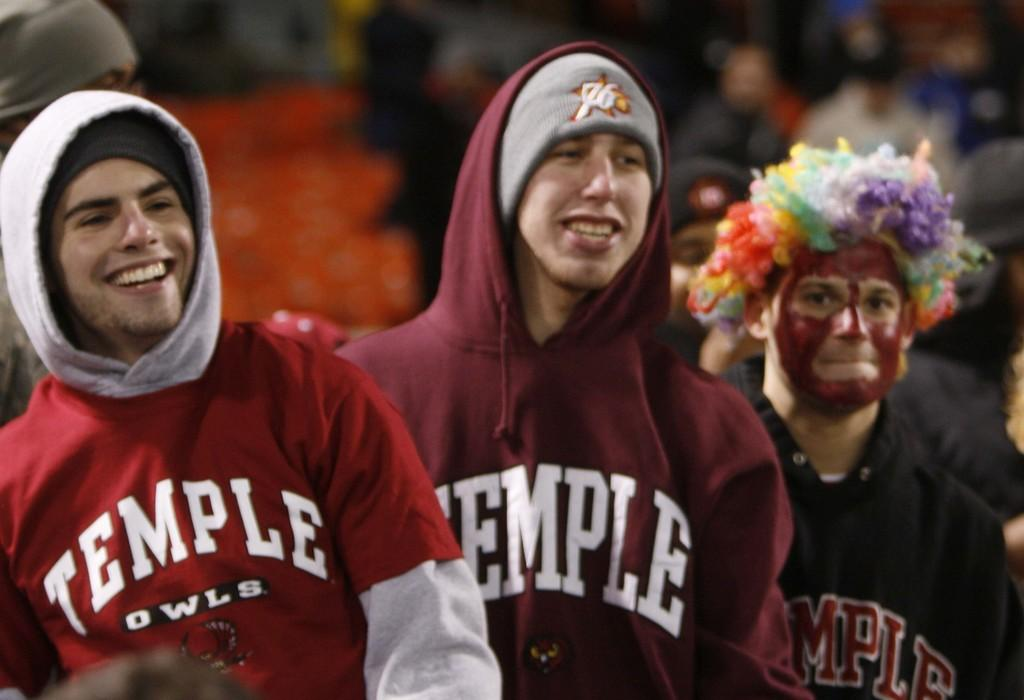<image>
Render a clear and concise summary of the photo. Three men are wearing clothing that says TEMPLE on them. 